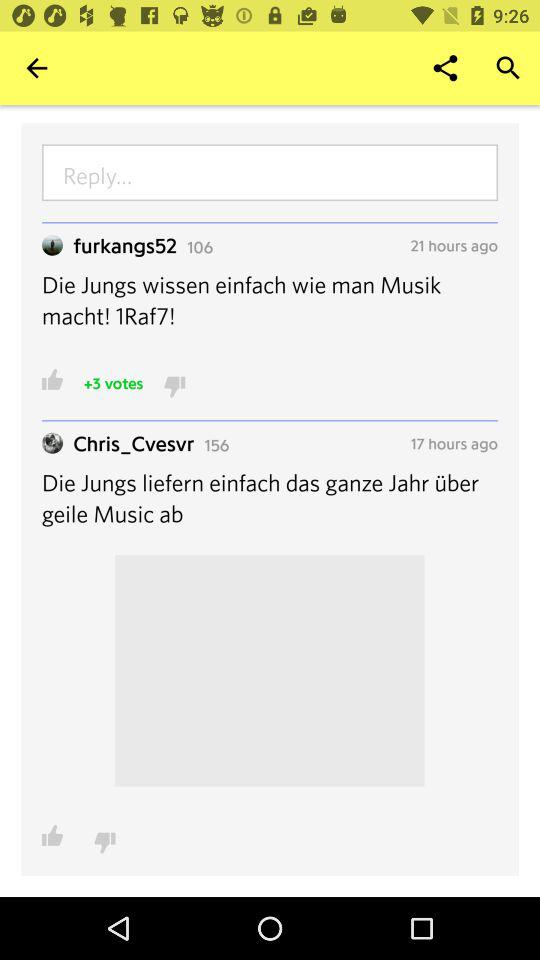How many more hours ago was the first comment posted than the second comment?
Answer the question using a single word or phrase. 4 